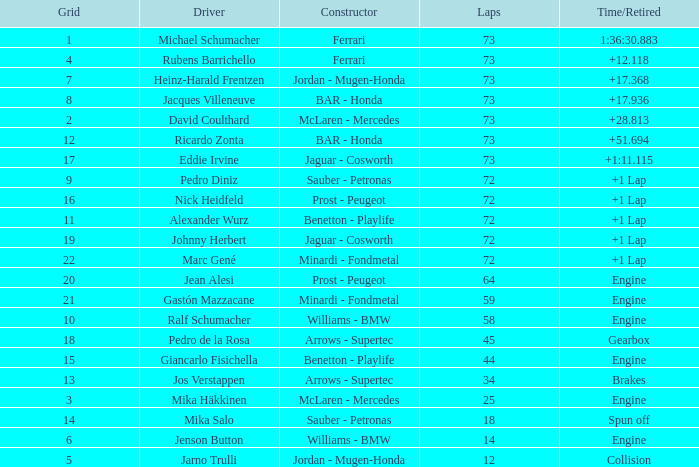How many laps did Jos Verstappen do on Grid 2? 34.0. 